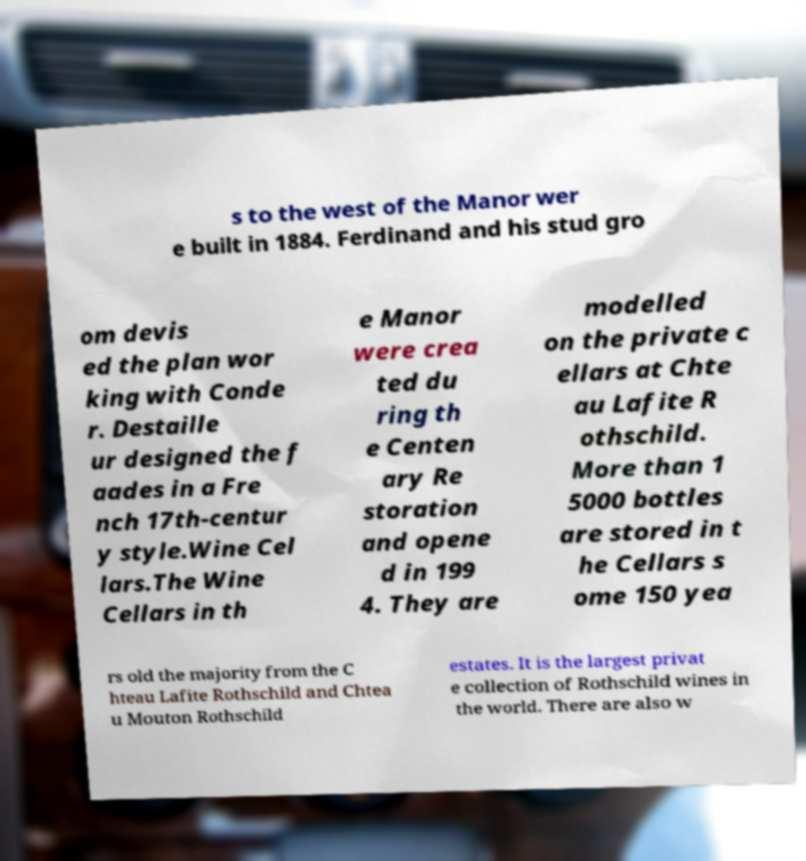Can you read and provide the text displayed in the image?This photo seems to have some interesting text. Can you extract and type it out for me? s to the west of the Manor wer e built in 1884. Ferdinand and his stud gro om devis ed the plan wor king with Conde r. Destaille ur designed the f aades in a Fre nch 17th-centur y style.Wine Cel lars.The Wine Cellars in th e Manor were crea ted du ring th e Centen ary Re storation and opene d in 199 4. They are modelled on the private c ellars at Chte au Lafite R othschild. More than 1 5000 bottles are stored in t he Cellars s ome 150 yea rs old the majority from the C hteau Lafite Rothschild and Chtea u Mouton Rothschild estates. It is the largest privat e collection of Rothschild wines in the world. There are also w 